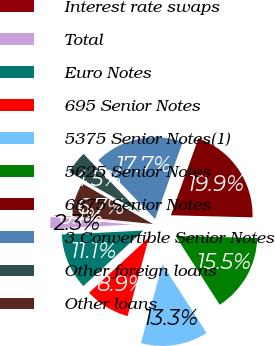Convert chart. <chart><loc_0><loc_0><loc_500><loc_500><pie_chart><fcel>Interest rate swaps<fcel>Total<fcel>Euro Notes<fcel>695 Senior Notes<fcel>5375 Senior Notes(1)<fcel>5625 Senior Notes<fcel>6875 Senior Notes<fcel>3 Convertible Senior Notes<fcel>Other foreign loans<fcel>Other loans<nl><fcel>0.08%<fcel>2.28%<fcel>11.1%<fcel>8.9%<fcel>13.31%<fcel>15.51%<fcel>19.92%<fcel>17.72%<fcel>4.49%<fcel>6.69%<nl></chart> 